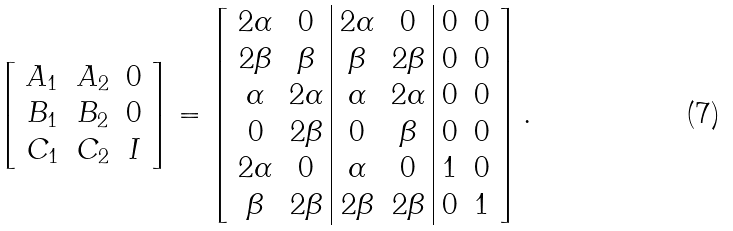Convert formula to latex. <formula><loc_0><loc_0><loc_500><loc_500>\left [ \begin{array} { c c c } A _ { 1 } & A _ { 2 } & 0 \\ B _ { 1 } & B _ { 2 } & 0 \\ C _ { 1 } & C _ { 2 } & I \\ \end{array} \right ] = \left [ \begin{array} { c c | c c | c c } 2 \alpha & 0 & 2 \alpha & 0 & 0 & 0 \\ 2 \beta & \beta & \beta & 2 \beta & 0 & 0 \\ \alpha & 2 \alpha & \alpha & 2 \alpha & 0 & 0 \\ 0 & 2 \beta & 0 & \beta & 0 & 0 \\ 2 \alpha & 0 & \alpha & 0 & 1 & 0 \\ \beta & 2 \beta & 2 \beta & 2 \beta & 0 & 1 \\ \end{array} \right ] .</formula> 